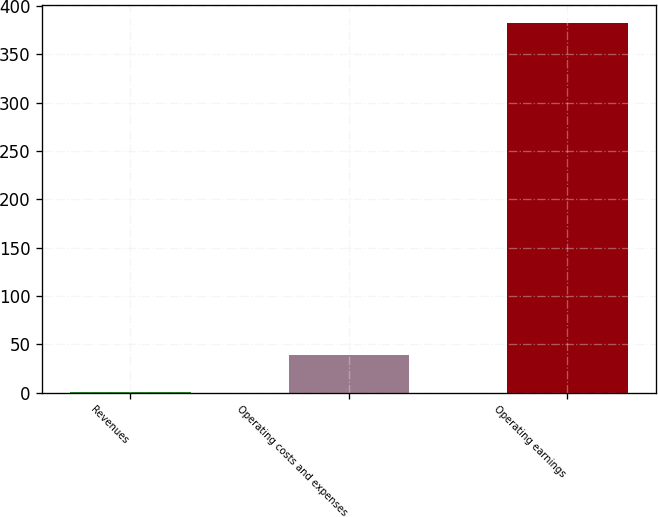Convert chart to OTSL. <chart><loc_0><loc_0><loc_500><loc_500><bar_chart><fcel>Revenues<fcel>Operating costs and expenses<fcel>Operating earnings<nl><fcel>0.2<fcel>38.4<fcel>382.2<nl></chart> 